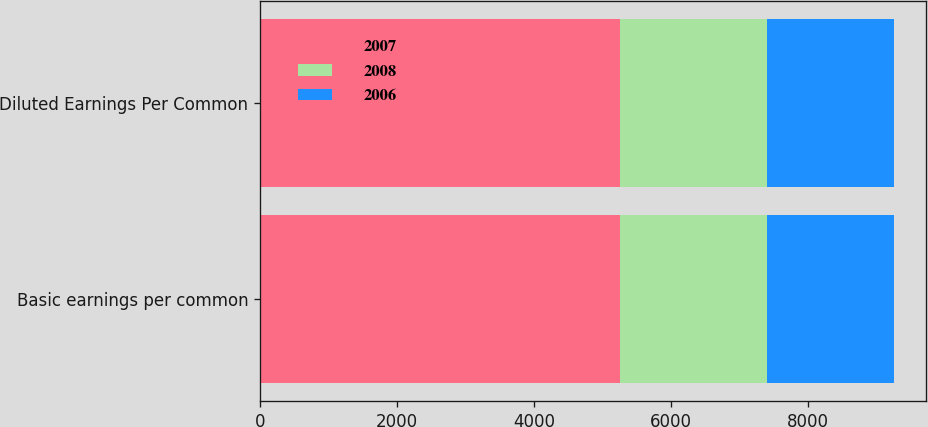Convert chart to OTSL. <chart><loc_0><loc_0><loc_500><loc_500><stacked_bar_chart><ecel><fcel>Basic earnings per common<fcel>Diluted Earnings Per Common<nl><fcel>2007<fcel>5257<fcel>5257<nl><fcel>2008<fcel>2150<fcel>2150<nl><fcel>2006<fcel>1855<fcel>1855<nl></chart> 